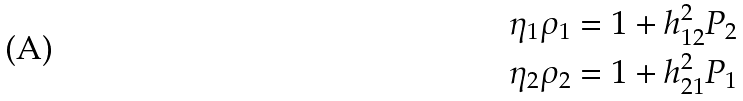<formula> <loc_0><loc_0><loc_500><loc_500>\eta _ { 1 } \rho _ { 1 } = & \ 1 + h _ { 1 2 } ^ { 2 } P _ { 2 } \\ \eta _ { 2 } \rho _ { 2 } = & \ 1 + h _ { 2 1 } ^ { 2 } P _ { 1 }</formula> 